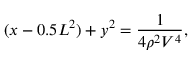Convert formula to latex. <formula><loc_0><loc_0><loc_500><loc_500>( x - 0 . 5 L ^ { 2 } ) + y ^ { 2 } = \frac { 1 } { 4 \rho ^ { 2 } V ^ { 4 } } ,</formula> 